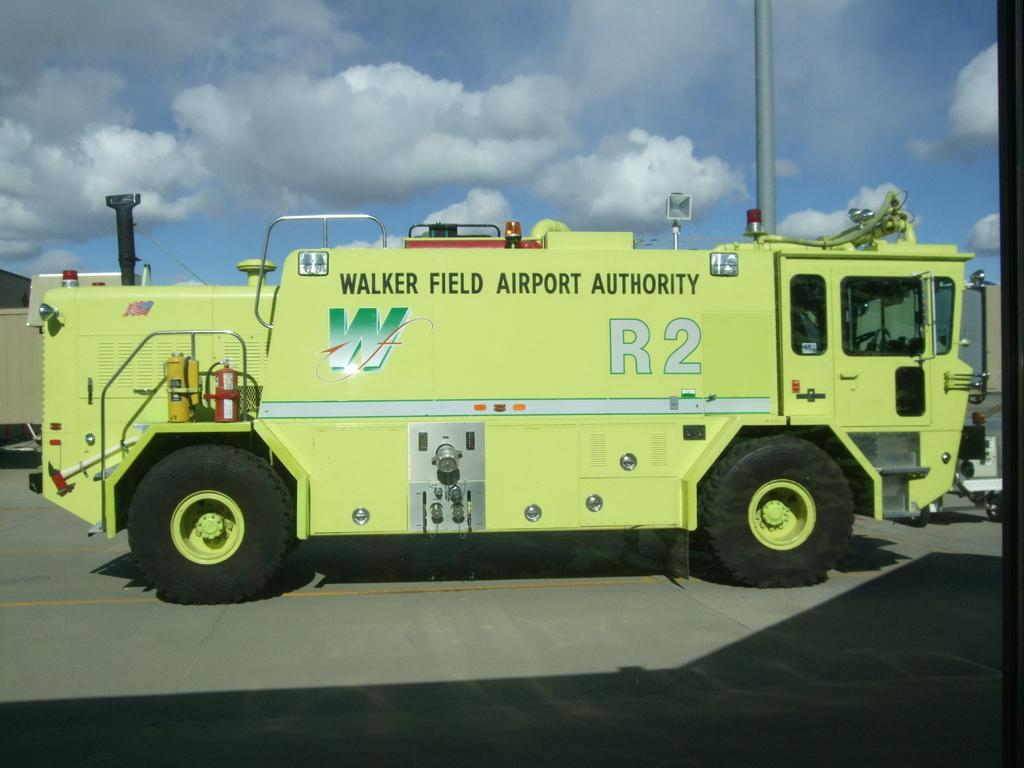What type of vehicle is in the picture? There is a vehicle of walker field authority of the airport in the picture. What color is the vehicle? The vehicle is yellow in color. What is located behind the vehicle? There is a pole behind the vehicle. What can be seen in the sky in the image? The sky is visible in the image, and clouds are present in the sky. Is there a vessel carrying a ladybug on a slope in the image? No, there is no vessel carrying a ladybug on a slope in the image. 